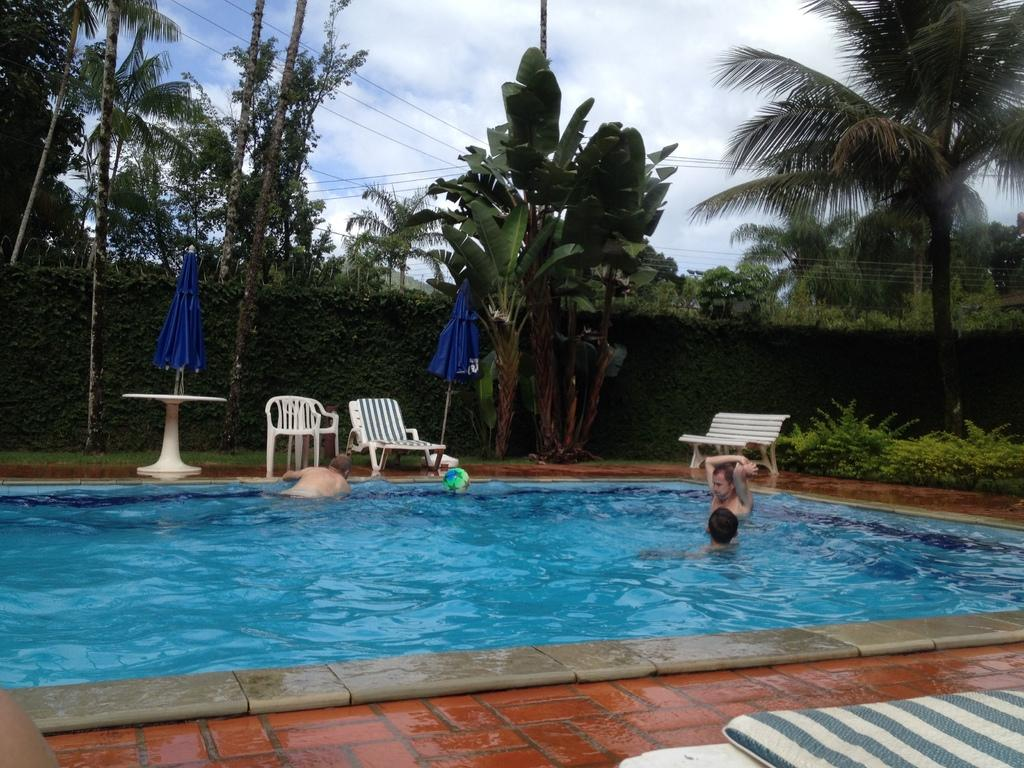Where was the image taken? The image was taken outdoors. What is the main feature in the center of the image? There is a swimming pool in the center of the image. What are the people in the image doing? Three people are swimming in the pool. What furniture can be seen in the background of the image? There is a table, chairs, and a bench in the background of the image. What type of natural environment is visible in the background of the image? Trees and the sky are visible in the background of the image. What type of toothpaste is being used by the swimmers in the image? There is no toothpaste present in the image; it is a swimming pool with people swimming in it. What kind of insurance policy is being discussed by the people sitting on the bench in the image? There is no discussion of insurance in the image; it features a swimming pool and people swimming in it. 